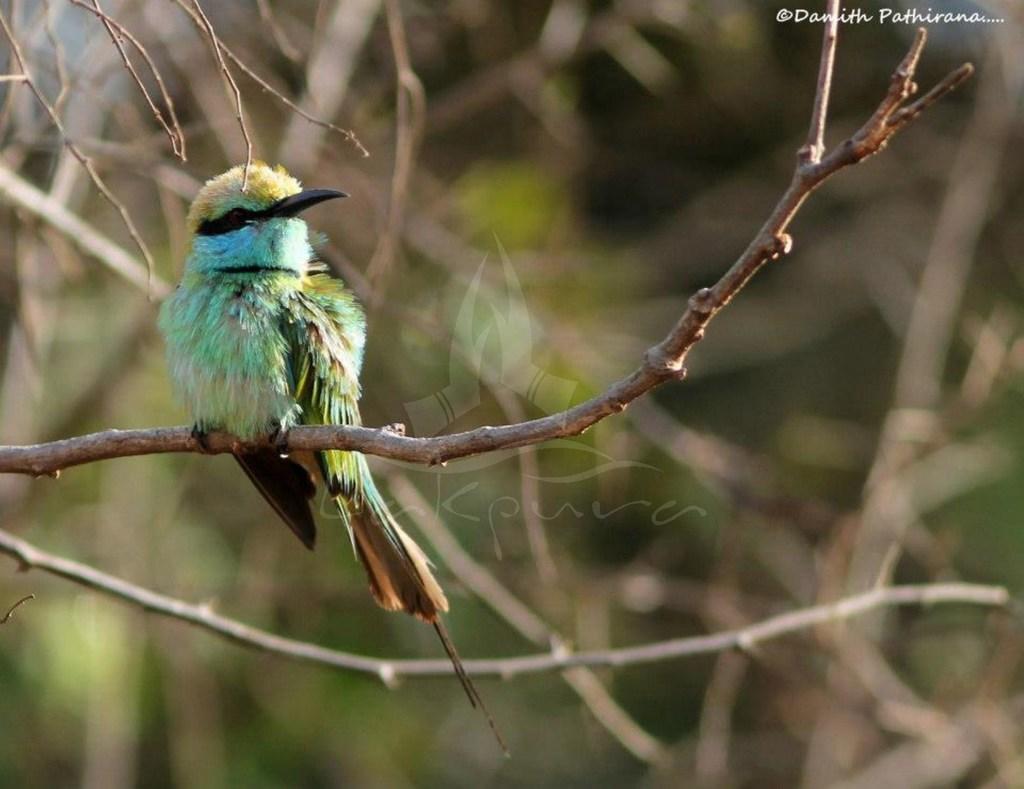Can you describe this image briefly? In the image in the center we can see one bird on a branch. On the right top we can see watermark. In the background we can see trees. 